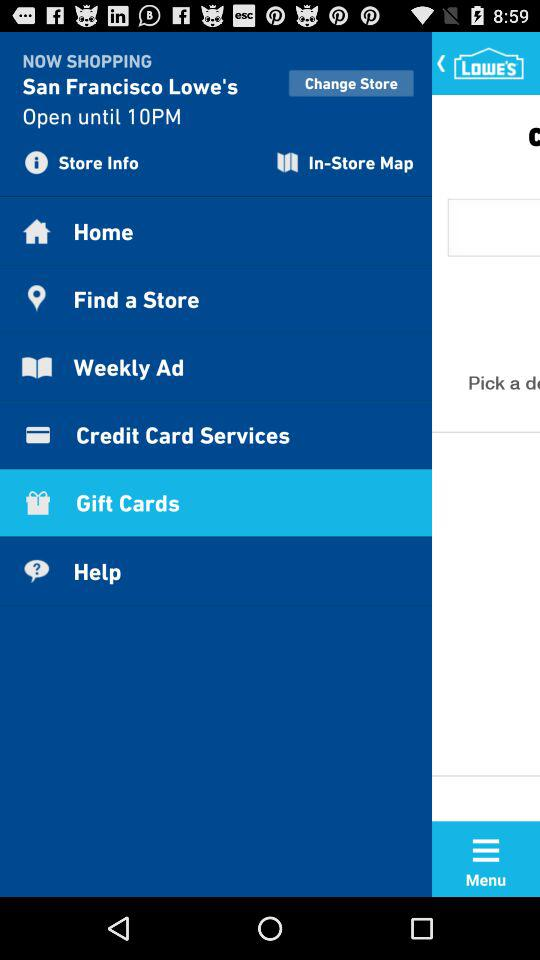What's the store name? The store name is "San Francisco Lowe's". 